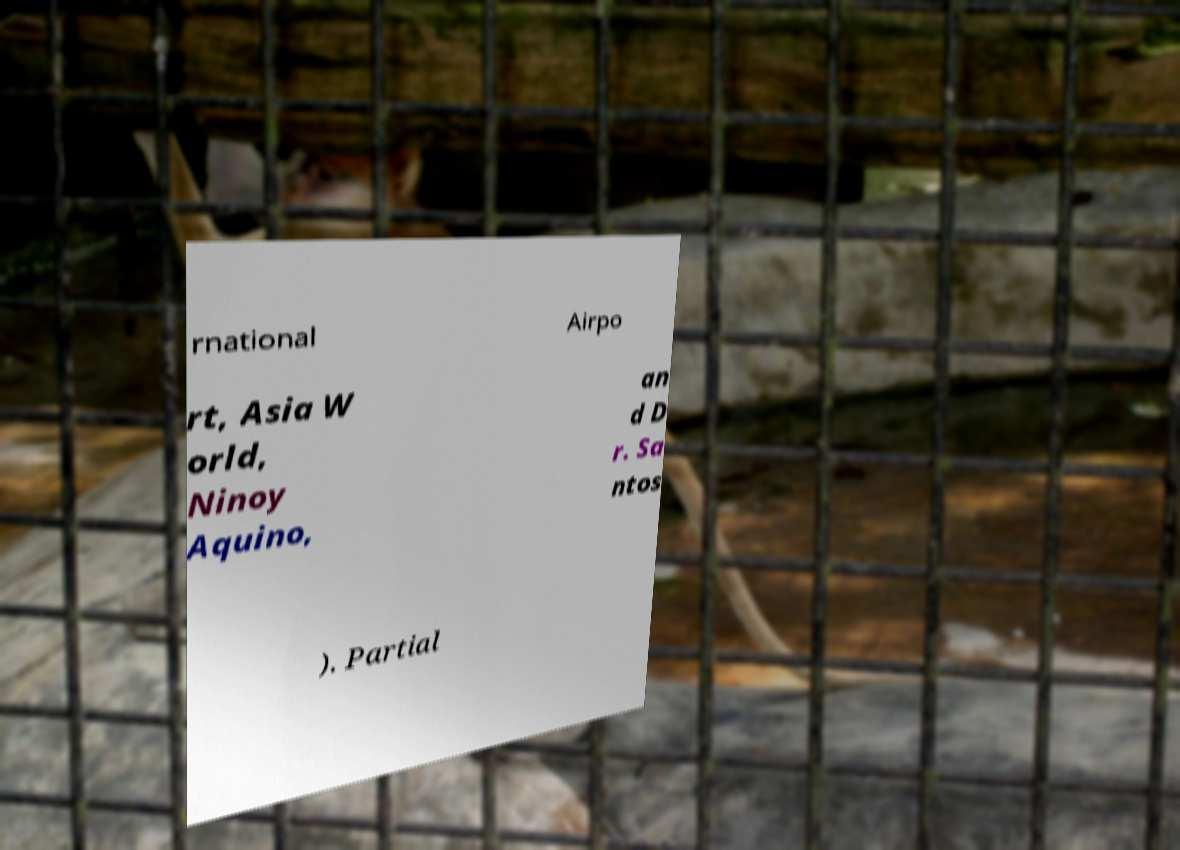Could you assist in decoding the text presented in this image and type it out clearly? rnational Airpo rt, Asia W orld, Ninoy Aquino, an d D r. Sa ntos ). Partial 